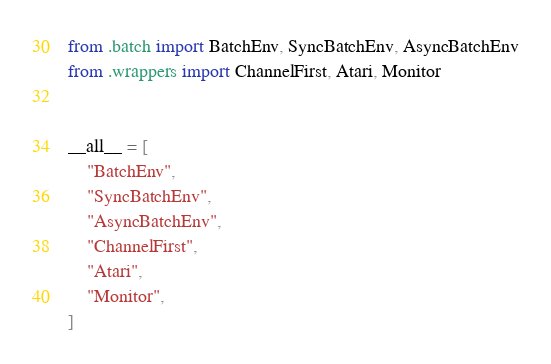Convert code to text. <code><loc_0><loc_0><loc_500><loc_500><_Python_>from .batch import BatchEnv, SyncBatchEnv, AsyncBatchEnv
from .wrappers import ChannelFirst, Atari, Monitor


__all__ = [
    "BatchEnv",
    "SyncBatchEnv",
    "AsyncBatchEnv",
    "ChannelFirst",
    "Atari",
    "Monitor",
]
</code> 